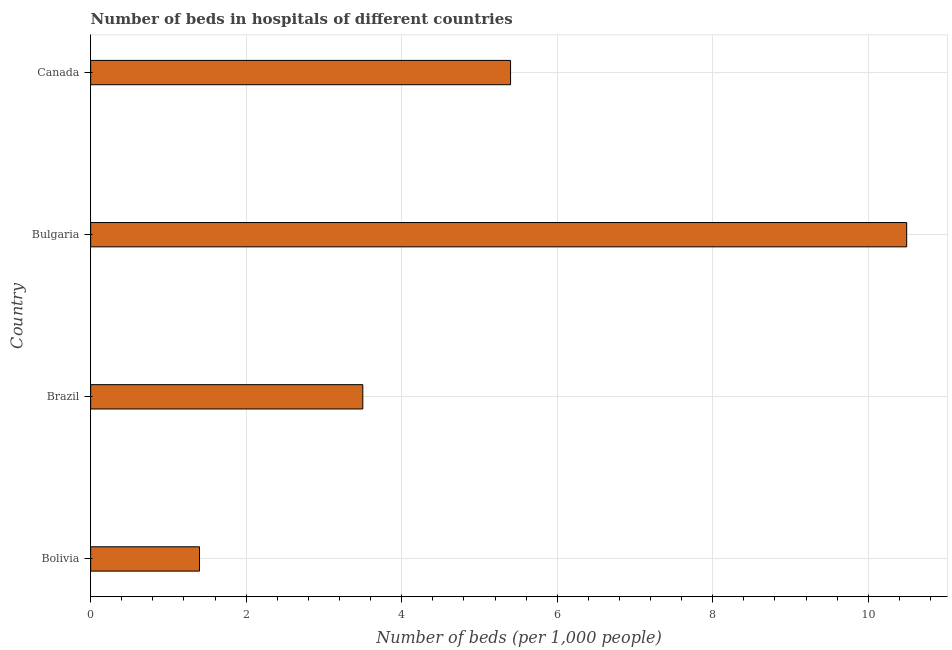Does the graph contain any zero values?
Keep it short and to the point. No. Does the graph contain grids?
Your answer should be very brief. Yes. What is the title of the graph?
Keep it short and to the point. Number of beds in hospitals of different countries. What is the label or title of the X-axis?
Provide a succinct answer. Number of beds (per 1,0 people). What is the label or title of the Y-axis?
Offer a very short reply. Country. What is the number of hospital beds in Bulgaria?
Offer a terse response. 10.49. Across all countries, what is the maximum number of hospital beds?
Provide a succinct answer. 10.49. Across all countries, what is the minimum number of hospital beds?
Make the answer very short. 1.4. In which country was the number of hospital beds minimum?
Provide a succinct answer. Bolivia. What is the sum of the number of hospital beds?
Ensure brevity in your answer.  20.79. What is the difference between the number of hospital beds in Bolivia and Bulgaria?
Your answer should be compact. -9.09. What is the average number of hospital beds per country?
Ensure brevity in your answer.  5.2. What is the median number of hospital beds?
Provide a short and direct response. 4.45. In how many countries, is the number of hospital beds greater than 3.2 %?
Make the answer very short. 3. What is the ratio of the number of hospital beds in Bolivia to that in Bulgaria?
Offer a terse response. 0.13. Is the number of hospital beds in Brazil less than that in Canada?
Provide a succinct answer. Yes. Is the difference between the number of hospital beds in Bulgaria and Canada greater than the difference between any two countries?
Your answer should be very brief. No. What is the difference between the highest and the second highest number of hospital beds?
Offer a very short reply. 5.09. Is the sum of the number of hospital beds in Bulgaria and Canada greater than the maximum number of hospital beds across all countries?
Provide a succinct answer. Yes. What is the difference between the highest and the lowest number of hospital beds?
Your response must be concise. 9.09. In how many countries, is the number of hospital beds greater than the average number of hospital beds taken over all countries?
Provide a succinct answer. 2. How many countries are there in the graph?
Offer a very short reply. 4. What is the Number of beds (per 1,000 people) in Bolivia?
Keep it short and to the point. 1.4. What is the Number of beds (per 1,000 people) in Brazil?
Make the answer very short. 3.5. What is the Number of beds (per 1,000 people) in Bulgaria?
Your answer should be very brief. 10.49. What is the Number of beds (per 1,000 people) of Canada?
Offer a terse response. 5.4. What is the difference between the Number of beds (per 1,000 people) in Bolivia and Bulgaria?
Offer a terse response. -9.09. What is the difference between the Number of beds (per 1,000 people) in Bolivia and Canada?
Your response must be concise. -4. What is the difference between the Number of beds (per 1,000 people) in Brazil and Bulgaria?
Make the answer very short. -6.99. What is the difference between the Number of beds (per 1,000 people) in Brazil and Canada?
Ensure brevity in your answer.  -1.9. What is the difference between the Number of beds (per 1,000 people) in Bulgaria and Canada?
Your answer should be very brief. 5.09. What is the ratio of the Number of beds (per 1,000 people) in Bolivia to that in Brazil?
Provide a short and direct response. 0.4. What is the ratio of the Number of beds (per 1,000 people) in Bolivia to that in Bulgaria?
Ensure brevity in your answer.  0.13. What is the ratio of the Number of beds (per 1,000 people) in Bolivia to that in Canada?
Give a very brief answer. 0.26. What is the ratio of the Number of beds (per 1,000 people) in Brazil to that in Bulgaria?
Keep it short and to the point. 0.33. What is the ratio of the Number of beds (per 1,000 people) in Brazil to that in Canada?
Provide a succinct answer. 0.65. What is the ratio of the Number of beds (per 1,000 people) in Bulgaria to that in Canada?
Your answer should be compact. 1.94. 